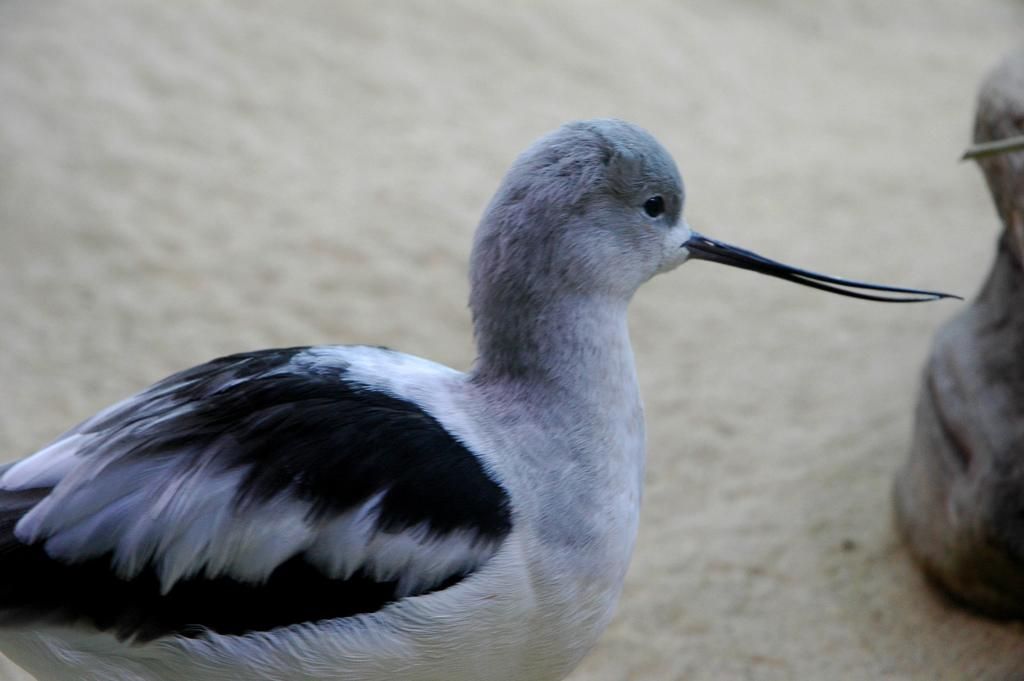What type of animal can be seen in the image? There is a bird in the image. Can you describe the object on the ground in the image? Unfortunately, the facts provided do not give any details about the object on the ground. However, we can confirm that there is an object present on the ground. What type of paste is the bird using to build its nest in the image? There is no mention of a nest or paste in the image. The bird is simply visible in the image. 